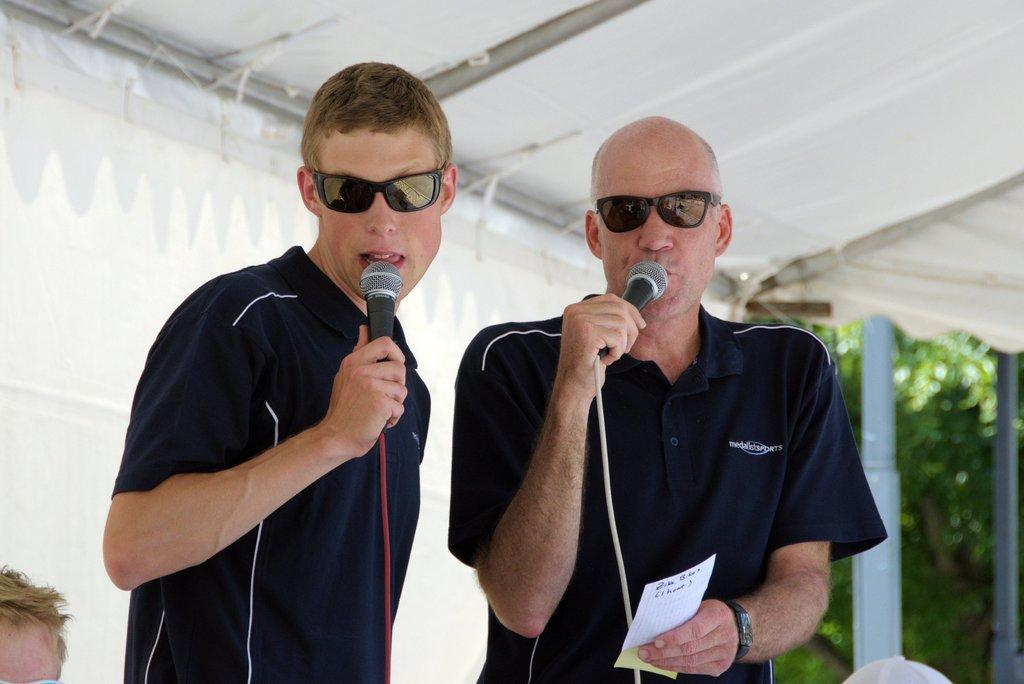How many people are in the image? There are two men in the image. What are the men holding in their hands? The men are holding microphones. What type of protective eyewear are the men wearing? The men are wearing goggles. What else is one of the men holding besides a microphone? One of the men is holding a card. What can be seen in the background of the image? There are trees visible in the background of the image. What type of grain is being harvested by the representative in the image? There is no representative or grain present in the image. How does the grip of the microphone affect the sound quality in the image? The grip of the microphone cannot be determined from the image, and its effect on sound quality cannot be assessed. 